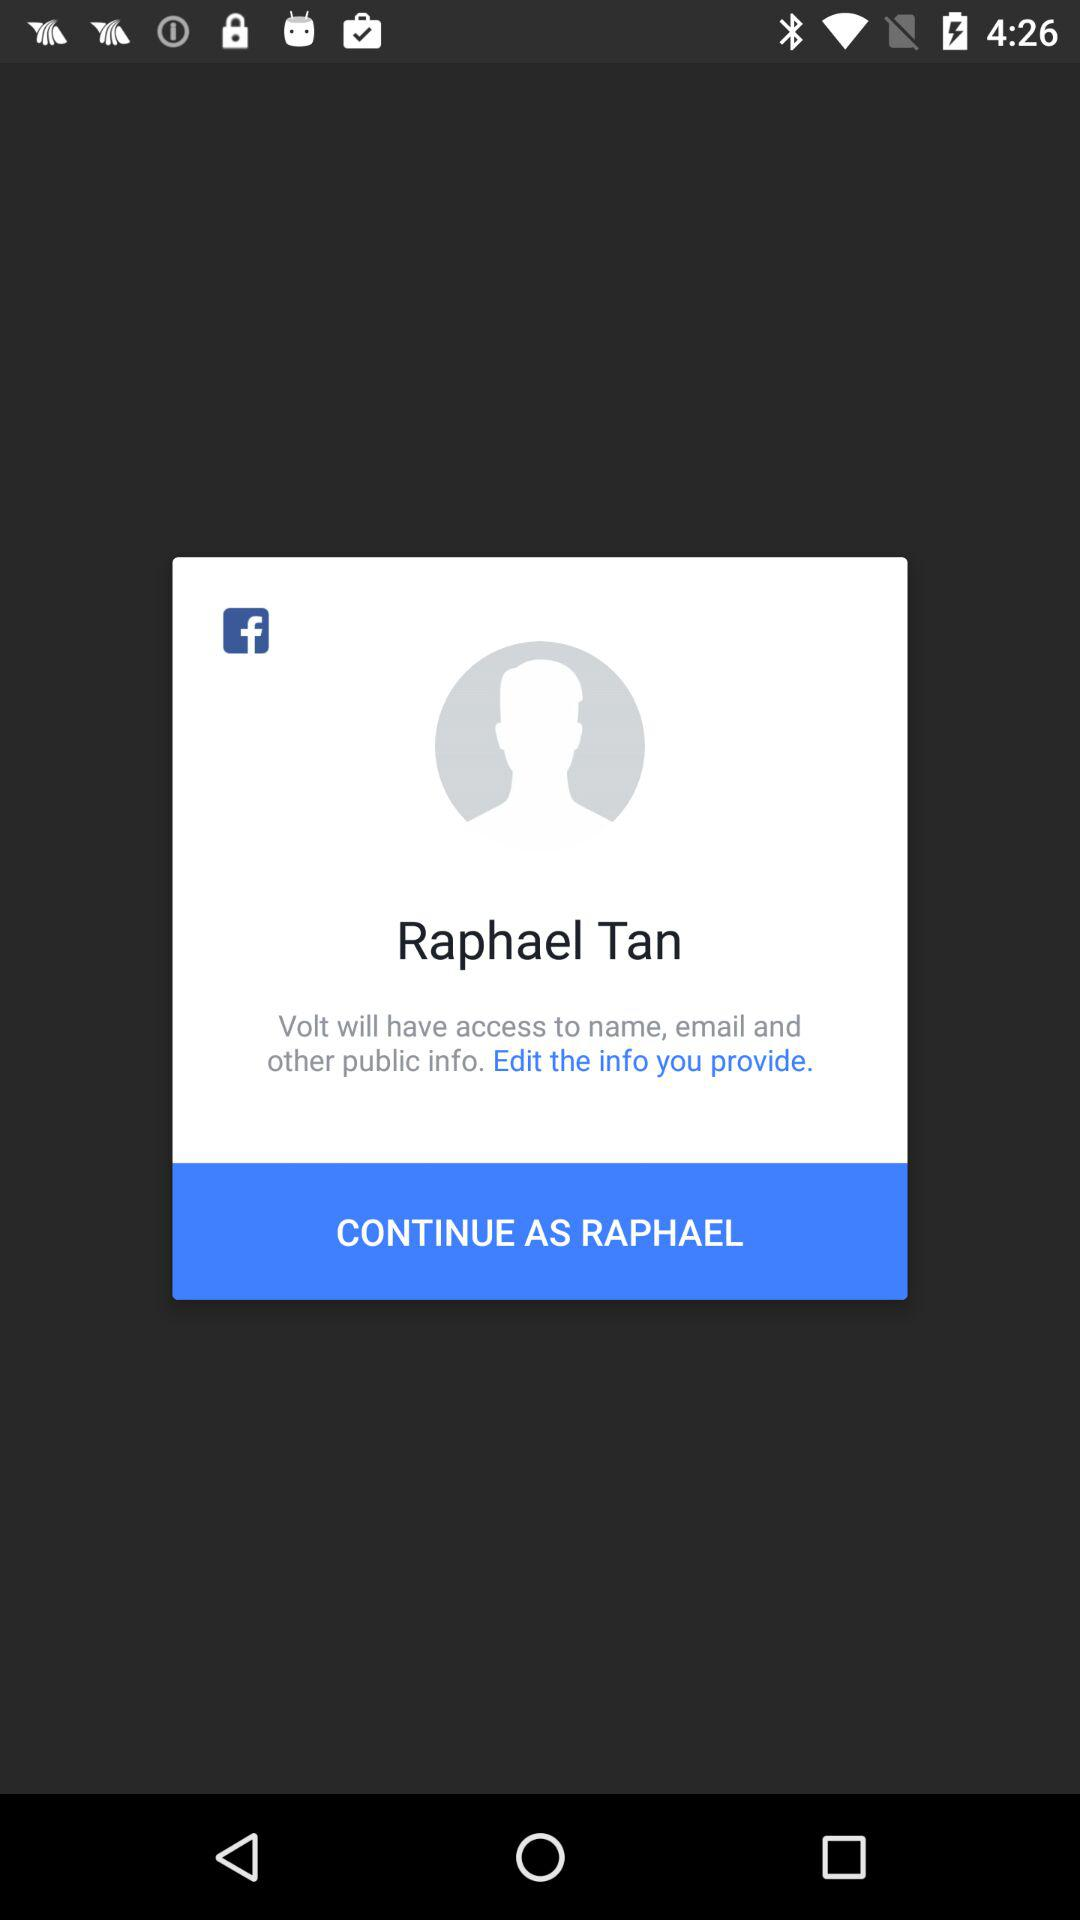What is the user name to continue on the login page? The user name is "Raphael Tan". 